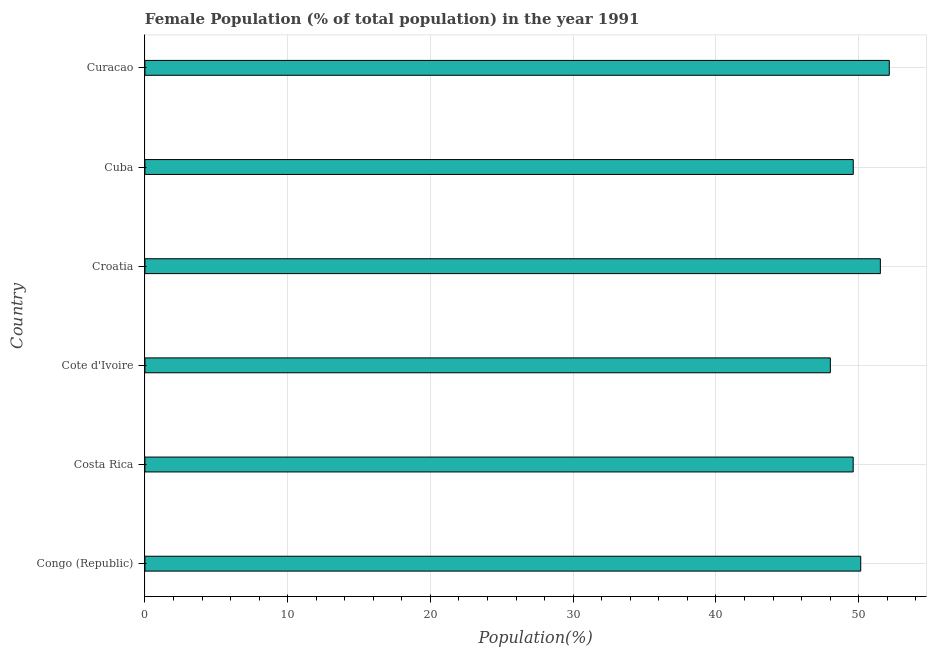What is the title of the graph?
Provide a succinct answer. Female Population (% of total population) in the year 1991. What is the label or title of the X-axis?
Keep it short and to the point. Population(%). What is the label or title of the Y-axis?
Ensure brevity in your answer.  Country. What is the female population in Curacao?
Your answer should be very brief. 52.14. Across all countries, what is the maximum female population?
Provide a succinct answer. 52.14. Across all countries, what is the minimum female population?
Your answer should be compact. 48.02. In which country was the female population maximum?
Your answer should be compact. Curacao. In which country was the female population minimum?
Ensure brevity in your answer.  Cote d'Ivoire. What is the sum of the female population?
Your answer should be compact. 301.06. What is the difference between the female population in Costa Rica and Cuba?
Your answer should be compact. -0. What is the average female population per country?
Offer a terse response. 50.18. What is the median female population?
Your answer should be very brief. 49.88. What is the ratio of the female population in Costa Rica to that in Cote d'Ivoire?
Ensure brevity in your answer.  1.03. Is the difference between the female population in Costa Rica and Croatia greater than the difference between any two countries?
Keep it short and to the point. No. What is the difference between the highest and the second highest female population?
Offer a terse response. 0.62. What is the difference between the highest and the lowest female population?
Your answer should be compact. 4.13. In how many countries, is the female population greater than the average female population taken over all countries?
Your response must be concise. 2. Are all the bars in the graph horizontal?
Keep it short and to the point. Yes. What is the difference between two consecutive major ticks on the X-axis?
Provide a short and direct response. 10. What is the Population(%) of Congo (Republic)?
Offer a very short reply. 50.14. What is the Population(%) of Costa Rica?
Keep it short and to the point. 49.62. What is the Population(%) of Cote d'Ivoire?
Give a very brief answer. 48.02. What is the Population(%) in Croatia?
Your answer should be very brief. 51.52. What is the Population(%) in Cuba?
Offer a terse response. 49.62. What is the Population(%) in Curacao?
Provide a short and direct response. 52.14. What is the difference between the Population(%) in Congo (Republic) and Costa Rica?
Ensure brevity in your answer.  0.53. What is the difference between the Population(%) in Congo (Republic) and Cote d'Ivoire?
Keep it short and to the point. 2.13. What is the difference between the Population(%) in Congo (Republic) and Croatia?
Offer a very short reply. -1.37. What is the difference between the Population(%) in Congo (Republic) and Cuba?
Your response must be concise. 0.52. What is the difference between the Population(%) in Congo (Republic) and Curacao?
Your response must be concise. -2. What is the difference between the Population(%) in Costa Rica and Cote d'Ivoire?
Provide a succinct answer. 1.6. What is the difference between the Population(%) in Costa Rica and Croatia?
Your answer should be very brief. -1.9. What is the difference between the Population(%) in Costa Rica and Cuba?
Provide a succinct answer. -0. What is the difference between the Population(%) in Costa Rica and Curacao?
Your response must be concise. -2.53. What is the difference between the Population(%) in Cote d'Ivoire and Croatia?
Give a very brief answer. -3.5. What is the difference between the Population(%) in Cote d'Ivoire and Cuba?
Offer a terse response. -1.6. What is the difference between the Population(%) in Cote d'Ivoire and Curacao?
Give a very brief answer. -4.13. What is the difference between the Population(%) in Croatia and Cuba?
Your answer should be very brief. 1.9. What is the difference between the Population(%) in Croatia and Curacao?
Provide a short and direct response. -0.63. What is the difference between the Population(%) in Cuba and Curacao?
Provide a succinct answer. -2.52. What is the ratio of the Population(%) in Congo (Republic) to that in Cote d'Ivoire?
Make the answer very short. 1.04. What is the ratio of the Population(%) in Congo (Republic) to that in Croatia?
Provide a short and direct response. 0.97. What is the ratio of the Population(%) in Congo (Republic) to that in Curacao?
Offer a terse response. 0.96. What is the ratio of the Population(%) in Costa Rica to that in Cote d'Ivoire?
Offer a very short reply. 1.03. What is the ratio of the Population(%) in Costa Rica to that in Croatia?
Your answer should be compact. 0.96. What is the ratio of the Population(%) in Costa Rica to that in Curacao?
Offer a terse response. 0.95. What is the ratio of the Population(%) in Cote d'Ivoire to that in Croatia?
Your answer should be compact. 0.93. What is the ratio of the Population(%) in Cote d'Ivoire to that in Curacao?
Make the answer very short. 0.92. What is the ratio of the Population(%) in Croatia to that in Cuba?
Your response must be concise. 1.04. 